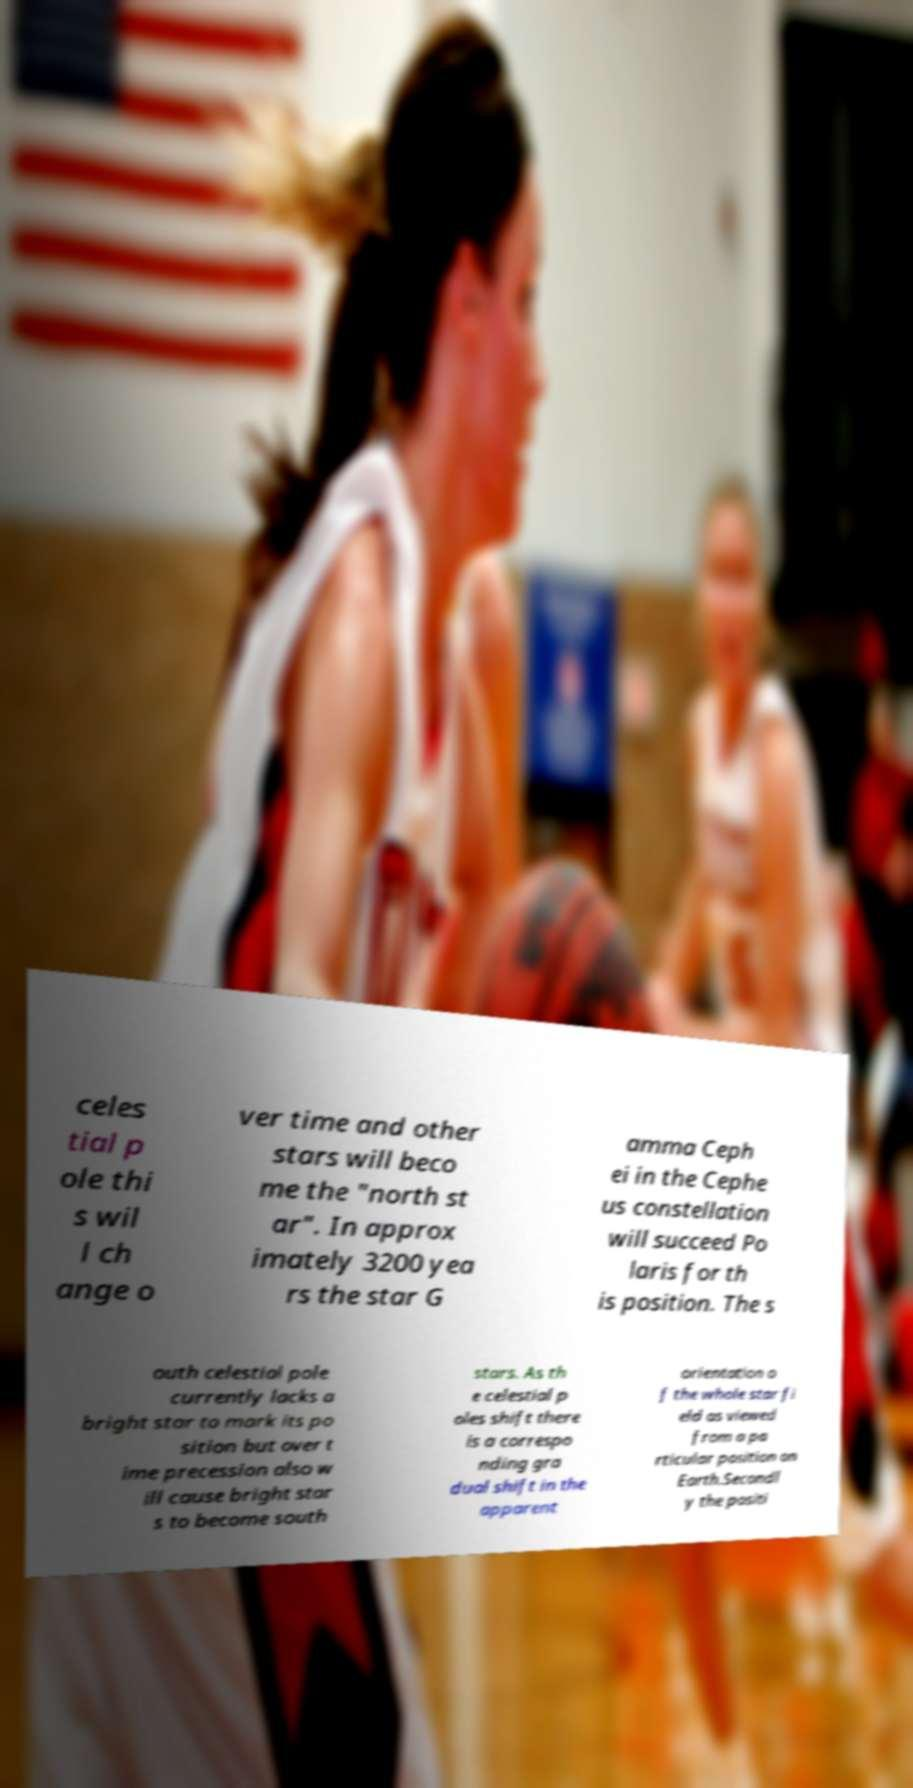Can you read and provide the text displayed in the image?This photo seems to have some interesting text. Can you extract and type it out for me? celes tial p ole thi s wil l ch ange o ver time and other stars will beco me the "north st ar". In approx imately 3200 yea rs the star G amma Ceph ei in the Cephe us constellation will succeed Po laris for th is position. The s outh celestial pole currently lacks a bright star to mark its po sition but over t ime precession also w ill cause bright star s to become south stars. As th e celestial p oles shift there is a correspo nding gra dual shift in the apparent orientation o f the whole star fi eld as viewed from a pa rticular position on Earth.Secondl y the positi 